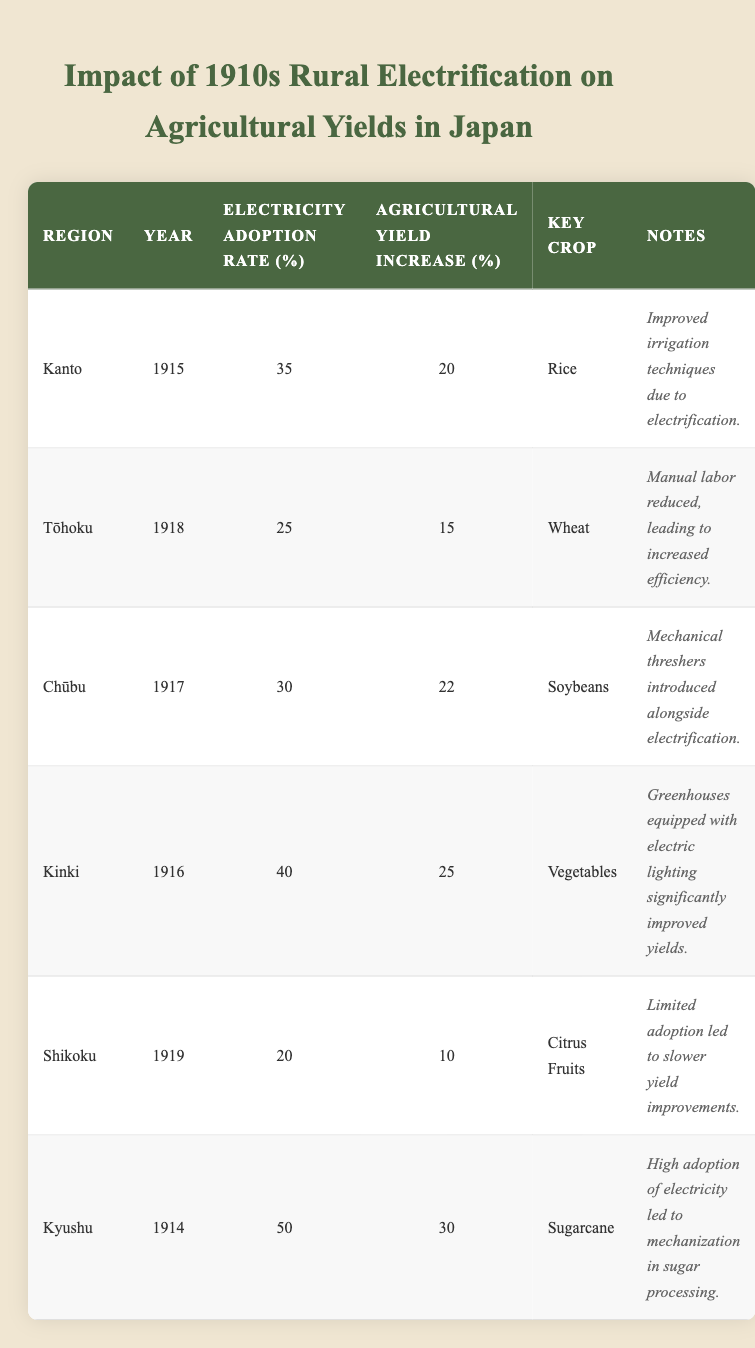What is the highest electricity adoption rate? By examining the "Electricity Adoption Rate (%)" column, the highest value is 50% in Kyushu in 1914.
Answer: 50% Which region had the lowest agricultural yield increase? Looking at the "Agricultural Yield Increase (%)" column, Shikoku, in 1919, had the lowest increase at 10%.
Answer: 10% What percentage of electricity adoption did Kinki achieve in 1916? According to the table, Kinki had an electricity adoption rate of 40% in the year 1916.
Answer: 40% Which key crop experienced the highest agricultural yield increase, and by how much? The key crop with the highest yield increase is Sugarcane in Kyushu with a 30% increase.
Answer: Sugarcane, 30% If we combine the agricultural yield increases of Kanto, Chūbu, and Kinki, what is the total increase? Adding the agricultural yield increases: Kanto (20%) + Chūbu (22%) + Kinki (25%) = 67%.
Answer: 67% Is it true that Tōhoku had a higher agricultural yield increase than Shikoku? Comparing the agricultural yield increases: Tōhoku (15%) and Shikoku (10%), Tōhoku is higher.
Answer: True What was the average electricity adoption rate across all regions listed? The total adoption rates are 35 + 25 + 30 + 40 + 20 + 50 = 200%. To find the average, we divide by 6 regions: 200 / 6 = 33.33%.
Answer: 33.33% Which region showed the greatest improvement in agricultural yields as a percentage increase? The greatest improvement is noted in Kyushu, where agricultural yield increased by 30%.
Answer: Kyushu, 30% Did the introduction of electrification generally lead to improved agricultural yields? Reviewing the data, all listed regions show an increase in agricultural yields after electrification, which suggests a positive trend.
Answer: Yes What is the percentage difference in agricultural yield increase between Kyushu and Tōhoku? The difference is calculated as follows: Kyushu had a 30% yield increase and Tōhoku had a 15% yield increase, so 30 - 15 = 15%.
Answer: 15% 